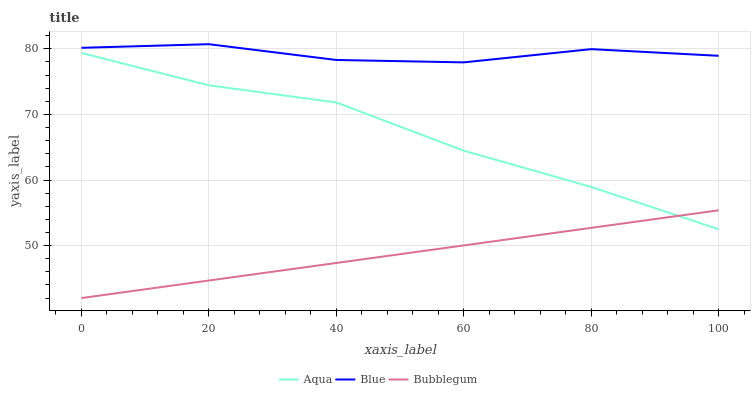Does Bubblegum have the minimum area under the curve?
Answer yes or no. Yes. Does Blue have the maximum area under the curve?
Answer yes or no. Yes. Does Aqua have the minimum area under the curve?
Answer yes or no. No. Does Aqua have the maximum area under the curve?
Answer yes or no. No. Is Bubblegum the smoothest?
Answer yes or no. Yes. Is Blue the roughest?
Answer yes or no. Yes. Is Aqua the smoothest?
Answer yes or no. No. Is Aqua the roughest?
Answer yes or no. No. Does Bubblegum have the lowest value?
Answer yes or no. Yes. Does Aqua have the lowest value?
Answer yes or no. No. Does Blue have the highest value?
Answer yes or no. Yes. Does Aqua have the highest value?
Answer yes or no. No. Is Aqua less than Blue?
Answer yes or no. Yes. Is Blue greater than Bubblegum?
Answer yes or no. Yes. Does Aqua intersect Bubblegum?
Answer yes or no. Yes. Is Aqua less than Bubblegum?
Answer yes or no. No. Is Aqua greater than Bubblegum?
Answer yes or no. No. Does Aqua intersect Blue?
Answer yes or no. No. 